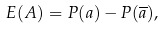Convert formula to latex. <formula><loc_0><loc_0><loc_500><loc_500>E ( A ) = P ( a ) - P ( \overline { a } ) ,</formula> 